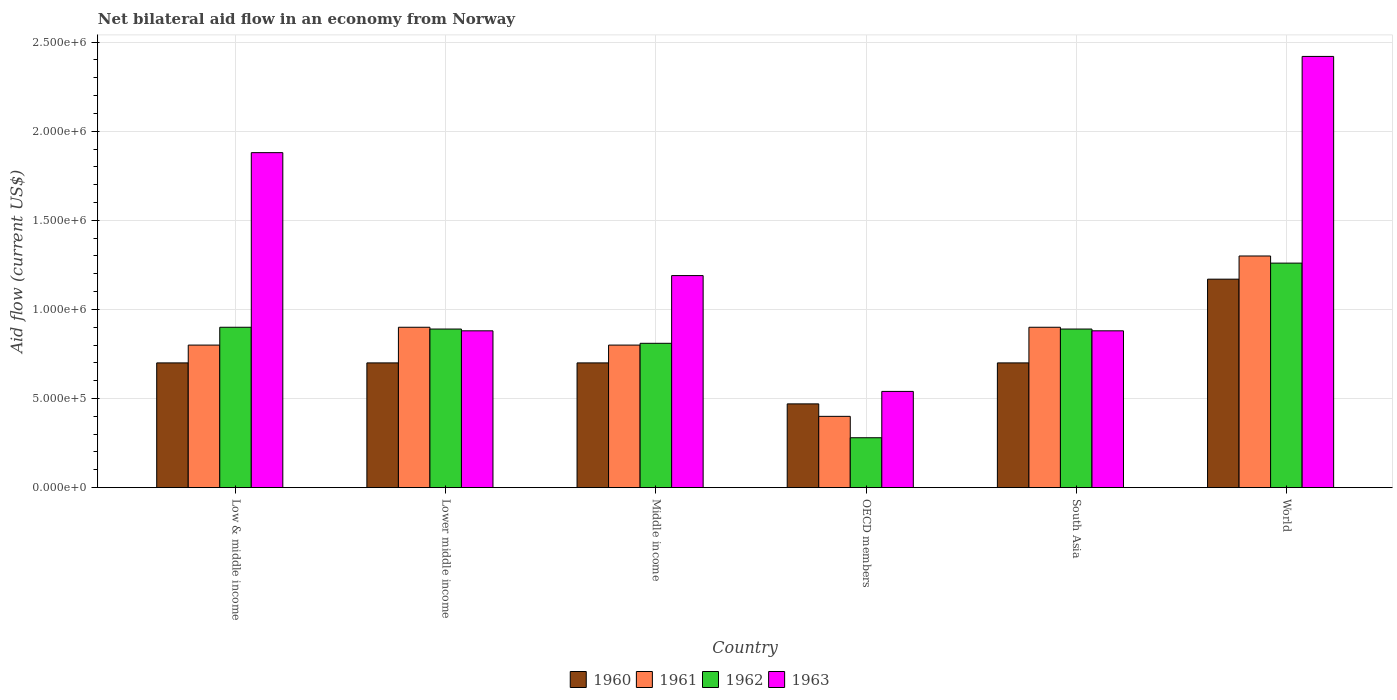How many different coloured bars are there?
Offer a very short reply. 4. How many groups of bars are there?
Make the answer very short. 6. Are the number of bars per tick equal to the number of legend labels?
Give a very brief answer. Yes. How many bars are there on the 6th tick from the right?
Offer a very short reply. 4. What is the label of the 6th group of bars from the left?
Provide a short and direct response. World. What is the net bilateral aid flow in 1961 in World?
Your answer should be very brief. 1.30e+06. Across all countries, what is the maximum net bilateral aid flow in 1963?
Your response must be concise. 2.42e+06. In which country was the net bilateral aid flow in 1961 minimum?
Provide a short and direct response. OECD members. What is the total net bilateral aid flow in 1960 in the graph?
Provide a short and direct response. 4.44e+06. What is the difference between the net bilateral aid flow in 1963 in Low & middle income and the net bilateral aid flow in 1961 in Middle income?
Ensure brevity in your answer.  1.08e+06. What is the average net bilateral aid flow in 1960 per country?
Make the answer very short. 7.40e+05. What is the difference between the net bilateral aid flow of/in 1962 and net bilateral aid flow of/in 1961 in Middle income?
Your answer should be compact. 10000. In how many countries, is the net bilateral aid flow in 1961 greater than 1200000 US$?
Your answer should be compact. 1. What is the ratio of the net bilateral aid flow in 1962 in Low & middle income to that in Middle income?
Provide a succinct answer. 1.11. What is the difference between the highest and the second highest net bilateral aid flow in 1962?
Offer a very short reply. 3.70e+05. What is the difference between the highest and the lowest net bilateral aid flow in 1963?
Give a very brief answer. 1.88e+06. In how many countries, is the net bilateral aid flow in 1962 greater than the average net bilateral aid flow in 1962 taken over all countries?
Make the answer very short. 4. What does the 2nd bar from the left in Low & middle income represents?
Provide a short and direct response. 1961. What does the 2nd bar from the right in Low & middle income represents?
Keep it short and to the point. 1962. Is it the case that in every country, the sum of the net bilateral aid flow in 1960 and net bilateral aid flow in 1962 is greater than the net bilateral aid flow in 1963?
Offer a terse response. No. Are all the bars in the graph horizontal?
Provide a succinct answer. No. How many countries are there in the graph?
Offer a terse response. 6. Are the values on the major ticks of Y-axis written in scientific E-notation?
Keep it short and to the point. Yes. Does the graph contain grids?
Make the answer very short. Yes. Where does the legend appear in the graph?
Provide a succinct answer. Bottom center. How are the legend labels stacked?
Your answer should be very brief. Horizontal. What is the title of the graph?
Offer a very short reply. Net bilateral aid flow in an economy from Norway. What is the Aid flow (current US$) in 1963 in Low & middle income?
Your answer should be very brief. 1.88e+06. What is the Aid flow (current US$) of 1961 in Lower middle income?
Provide a short and direct response. 9.00e+05. What is the Aid flow (current US$) in 1962 in Lower middle income?
Make the answer very short. 8.90e+05. What is the Aid flow (current US$) of 1963 in Lower middle income?
Your response must be concise. 8.80e+05. What is the Aid flow (current US$) in 1960 in Middle income?
Keep it short and to the point. 7.00e+05. What is the Aid flow (current US$) of 1961 in Middle income?
Keep it short and to the point. 8.00e+05. What is the Aid flow (current US$) in 1962 in Middle income?
Your answer should be compact. 8.10e+05. What is the Aid flow (current US$) in 1963 in Middle income?
Keep it short and to the point. 1.19e+06. What is the Aid flow (current US$) of 1961 in OECD members?
Your response must be concise. 4.00e+05. What is the Aid flow (current US$) of 1963 in OECD members?
Provide a short and direct response. 5.40e+05. What is the Aid flow (current US$) of 1961 in South Asia?
Provide a succinct answer. 9.00e+05. What is the Aid flow (current US$) of 1962 in South Asia?
Provide a short and direct response. 8.90e+05. What is the Aid flow (current US$) in 1963 in South Asia?
Ensure brevity in your answer.  8.80e+05. What is the Aid flow (current US$) of 1960 in World?
Provide a short and direct response. 1.17e+06. What is the Aid flow (current US$) in 1961 in World?
Provide a short and direct response. 1.30e+06. What is the Aid flow (current US$) in 1962 in World?
Your response must be concise. 1.26e+06. What is the Aid flow (current US$) in 1963 in World?
Offer a terse response. 2.42e+06. Across all countries, what is the maximum Aid flow (current US$) of 1960?
Your response must be concise. 1.17e+06. Across all countries, what is the maximum Aid flow (current US$) in 1961?
Keep it short and to the point. 1.30e+06. Across all countries, what is the maximum Aid flow (current US$) in 1962?
Provide a succinct answer. 1.26e+06. Across all countries, what is the maximum Aid flow (current US$) of 1963?
Provide a short and direct response. 2.42e+06. Across all countries, what is the minimum Aid flow (current US$) in 1961?
Provide a succinct answer. 4.00e+05. Across all countries, what is the minimum Aid flow (current US$) of 1963?
Offer a very short reply. 5.40e+05. What is the total Aid flow (current US$) of 1960 in the graph?
Your response must be concise. 4.44e+06. What is the total Aid flow (current US$) in 1961 in the graph?
Your response must be concise. 5.10e+06. What is the total Aid flow (current US$) in 1962 in the graph?
Provide a succinct answer. 5.03e+06. What is the total Aid flow (current US$) in 1963 in the graph?
Provide a short and direct response. 7.79e+06. What is the difference between the Aid flow (current US$) of 1960 in Low & middle income and that in Lower middle income?
Ensure brevity in your answer.  0. What is the difference between the Aid flow (current US$) of 1961 in Low & middle income and that in Lower middle income?
Offer a very short reply. -1.00e+05. What is the difference between the Aid flow (current US$) in 1962 in Low & middle income and that in Lower middle income?
Make the answer very short. 10000. What is the difference between the Aid flow (current US$) of 1961 in Low & middle income and that in Middle income?
Your response must be concise. 0. What is the difference between the Aid flow (current US$) in 1962 in Low & middle income and that in Middle income?
Ensure brevity in your answer.  9.00e+04. What is the difference between the Aid flow (current US$) in 1963 in Low & middle income and that in Middle income?
Your answer should be compact. 6.90e+05. What is the difference between the Aid flow (current US$) of 1962 in Low & middle income and that in OECD members?
Offer a very short reply. 6.20e+05. What is the difference between the Aid flow (current US$) in 1963 in Low & middle income and that in OECD members?
Offer a terse response. 1.34e+06. What is the difference between the Aid flow (current US$) of 1960 in Low & middle income and that in South Asia?
Your answer should be very brief. 0. What is the difference between the Aid flow (current US$) of 1961 in Low & middle income and that in South Asia?
Ensure brevity in your answer.  -1.00e+05. What is the difference between the Aid flow (current US$) in 1962 in Low & middle income and that in South Asia?
Make the answer very short. 10000. What is the difference between the Aid flow (current US$) in 1960 in Low & middle income and that in World?
Keep it short and to the point. -4.70e+05. What is the difference between the Aid flow (current US$) of 1961 in Low & middle income and that in World?
Offer a terse response. -5.00e+05. What is the difference between the Aid flow (current US$) in 1962 in Low & middle income and that in World?
Your answer should be compact. -3.60e+05. What is the difference between the Aid flow (current US$) of 1963 in Low & middle income and that in World?
Ensure brevity in your answer.  -5.40e+05. What is the difference between the Aid flow (current US$) in 1960 in Lower middle income and that in Middle income?
Make the answer very short. 0. What is the difference between the Aid flow (current US$) of 1961 in Lower middle income and that in Middle income?
Your answer should be very brief. 1.00e+05. What is the difference between the Aid flow (current US$) in 1962 in Lower middle income and that in Middle income?
Offer a terse response. 8.00e+04. What is the difference between the Aid flow (current US$) in 1963 in Lower middle income and that in Middle income?
Ensure brevity in your answer.  -3.10e+05. What is the difference between the Aid flow (current US$) of 1960 in Lower middle income and that in OECD members?
Your response must be concise. 2.30e+05. What is the difference between the Aid flow (current US$) of 1961 in Lower middle income and that in OECD members?
Make the answer very short. 5.00e+05. What is the difference between the Aid flow (current US$) in 1963 in Lower middle income and that in OECD members?
Make the answer very short. 3.40e+05. What is the difference between the Aid flow (current US$) of 1962 in Lower middle income and that in South Asia?
Ensure brevity in your answer.  0. What is the difference between the Aid flow (current US$) of 1960 in Lower middle income and that in World?
Your answer should be very brief. -4.70e+05. What is the difference between the Aid flow (current US$) of 1961 in Lower middle income and that in World?
Your response must be concise. -4.00e+05. What is the difference between the Aid flow (current US$) in 1962 in Lower middle income and that in World?
Your answer should be compact. -3.70e+05. What is the difference between the Aid flow (current US$) of 1963 in Lower middle income and that in World?
Your response must be concise. -1.54e+06. What is the difference between the Aid flow (current US$) in 1962 in Middle income and that in OECD members?
Your answer should be compact. 5.30e+05. What is the difference between the Aid flow (current US$) in 1963 in Middle income and that in OECD members?
Provide a succinct answer. 6.50e+05. What is the difference between the Aid flow (current US$) in 1961 in Middle income and that in South Asia?
Your answer should be compact. -1.00e+05. What is the difference between the Aid flow (current US$) of 1963 in Middle income and that in South Asia?
Ensure brevity in your answer.  3.10e+05. What is the difference between the Aid flow (current US$) in 1960 in Middle income and that in World?
Your answer should be compact. -4.70e+05. What is the difference between the Aid flow (current US$) of 1961 in Middle income and that in World?
Your response must be concise. -5.00e+05. What is the difference between the Aid flow (current US$) of 1962 in Middle income and that in World?
Your answer should be compact. -4.50e+05. What is the difference between the Aid flow (current US$) in 1963 in Middle income and that in World?
Your response must be concise. -1.23e+06. What is the difference between the Aid flow (current US$) of 1960 in OECD members and that in South Asia?
Make the answer very short. -2.30e+05. What is the difference between the Aid flow (current US$) in 1961 in OECD members and that in South Asia?
Your response must be concise. -5.00e+05. What is the difference between the Aid flow (current US$) in 1962 in OECD members and that in South Asia?
Offer a very short reply. -6.10e+05. What is the difference between the Aid flow (current US$) of 1963 in OECD members and that in South Asia?
Offer a very short reply. -3.40e+05. What is the difference between the Aid flow (current US$) of 1960 in OECD members and that in World?
Keep it short and to the point. -7.00e+05. What is the difference between the Aid flow (current US$) of 1961 in OECD members and that in World?
Make the answer very short. -9.00e+05. What is the difference between the Aid flow (current US$) of 1962 in OECD members and that in World?
Your response must be concise. -9.80e+05. What is the difference between the Aid flow (current US$) of 1963 in OECD members and that in World?
Give a very brief answer. -1.88e+06. What is the difference between the Aid flow (current US$) of 1960 in South Asia and that in World?
Keep it short and to the point. -4.70e+05. What is the difference between the Aid flow (current US$) of 1961 in South Asia and that in World?
Your answer should be compact. -4.00e+05. What is the difference between the Aid flow (current US$) of 1962 in South Asia and that in World?
Your answer should be compact. -3.70e+05. What is the difference between the Aid flow (current US$) of 1963 in South Asia and that in World?
Your response must be concise. -1.54e+06. What is the difference between the Aid flow (current US$) of 1960 in Low & middle income and the Aid flow (current US$) of 1962 in Lower middle income?
Provide a short and direct response. -1.90e+05. What is the difference between the Aid flow (current US$) in 1960 in Low & middle income and the Aid flow (current US$) in 1963 in Lower middle income?
Your answer should be very brief. -1.80e+05. What is the difference between the Aid flow (current US$) in 1961 in Low & middle income and the Aid flow (current US$) in 1963 in Lower middle income?
Make the answer very short. -8.00e+04. What is the difference between the Aid flow (current US$) in 1962 in Low & middle income and the Aid flow (current US$) in 1963 in Lower middle income?
Offer a terse response. 2.00e+04. What is the difference between the Aid flow (current US$) in 1960 in Low & middle income and the Aid flow (current US$) in 1963 in Middle income?
Keep it short and to the point. -4.90e+05. What is the difference between the Aid flow (current US$) in 1961 in Low & middle income and the Aid flow (current US$) in 1962 in Middle income?
Keep it short and to the point. -10000. What is the difference between the Aid flow (current US$) of 1961 in Low & middle income and the Aid flow (current US$) of 1963 in Middle income?
Provide a succinct answer. -3.90e+05. What is the difference between the Aid flow (current US$) of 1962 in Low & middle income and the Aid flow (current US$) of 1963 in Middle income?
Offer a terse response. -2.90e+05. What is the difference between the Aid flow (current US$) in 1960 in Low & middle income and the Aid flow (current US$) in 1962 in OECD members?
Give a very brief answer. 4.20e+05. What is the difference between the Aid flow (current US$) in 1960 in Low & middle income and the Aid flow (current US$) in 1963 in OECD members?
Ensure brevity in your answer.  1.60e+05. What is the difference between the Aid flow (current US$) of 1961 in Low & middle income and the Aid flow (current US$) of 1962 in OECD members?
Your response must be concise. 5.20e+05. What is the difference between the Aid flow (current US$) of 1962 in Low & middle income and the Aid flow (current US$) of 1963 in OECD members?
Keep it short and to the point. 3.60e+05. What is the difference between the Aid flow (current US$) in 1960 in Low & middle income and the Aid flow (current US$) in 1961 in South Asia?
Offer a very short reply. -2.00e+05. What is the difference between the Aid flow (current US$) in 1960 in Low & middle income and the Aid flow (current US$) in 1963 in South Asia?
Offer a terse response. -1.80e+05. What is the difference between the Aid flow (current US$) in 1960 in Low & middle income and the Aid flow (current US$) in 1961 in World?
Give a very brief answer. -6.00e+05. What is the difference between the Aid flow (current US$) of 1960 in Low & middle income and the Aid flow (current US$) of 1962 in World?
Provide a succinct answer. -5.60e+05. What is the difference between the Aid flow (current US$) in 1960 in Low & middle income and the Aid flow (current US$) in 1963 in World?
Your response must be concise. -1.72e+06. What is the difference between the Aid flow (current US$) of 1961 in Low & middle income and the Aid flow (current US$) of 1962 in World?
Offer a terse response. -4.60e+05. What is the difference between the Aid flow (current US$) in 1961 in Low & middle income and the Aid flow (current US$) in 1963 in World?
Offer a terse response. -1.62e+06. What is the difference between the Aid flow (current US$) of 1962 in Low & middle income and the Aid flow (current US$) of 1963 in World?
Ensure brevity in your answer.  -1.52e+06. What is the difference between the Aid flow (current US$) in 1960 in Lower middle income and the Aid flow (current US$) in 1962 in Middle income?
Provide a short and direct response. -1.10e+05. What is the difference between the Aid flow (current US$) in 1960 in Lower middle income and the Aid flow (current US$) in 1963 in Middle income?
Make the answer very short. -4.90e+05. What is the difference between the Aid flow (current US$) of 1961 in Lower middle income and the Aid flow (current US$) of 1962 in OECD members?
Keep it short and to the point. 6.20e+05. What is the difference between the Aid flow (current US$) in 1960 in Lower middle income and the Aid flow (current US$) in 1961 in South Asia?
Offer a terse response. -2.00e+05. What is the difference between the Aid flow (current US$) of 1960 in Lower middle income and the Aid flow (current US$) of 1963 in South Asia?
Offer a terse response. -1.80e+05. What is the difference between the Aid flow (current US$) of 1961 in Lower middle income and the Aid flow (current US$) of 1963 in South Asia?
Provide a succinct answer. 2.00e+04. What is the difference between the Aid flow (current US$) in 1960 in Lower middle income and the Aid flow (current US$) in 1961 in World?
Keep it short and to the point. -6.00e+05. What is the difference between the Aid flow (current US$) of 1960 in Lower middle income and the Aid flow (current US$) of 1962 in World?
Make the answer very short. -5.60e+05. What is the difference between the Aid flow (current US$) in 1960 in Lower middle income and the Aid flow (current US$) in 1963 in World?
Your answer should be compact. -1.72e+06. What is the difference between the Aid flow (current US$) in 1961 in Lower middle income and the Aid flow (current US$) in 1962 in World?
Provide a short and direct response. -3.60e+05. What is the difference between the Aid flow (current US$) of 1961 in Lower middle income and the Aid flow (current US$) of 1963 in World?
Your answer should be compact. -1.52e+06. What is the difference between the Aid flow (current US$) in 1962 in Lower middle income and the Aid flow (current US$) in 1963 in World?
Ensure brevity in your answer.  -1.53e+06. What is the difference between the Aid flow (current US$) in 1961 in Middle income and the Aid flow (current US$) in 1962 in OECD members?
Offer a terse response. 5.20e+05. What is the difference between the Aid flow (current US$) in 1962 in Middle income and the Aid flow (current US$) in 1963 in OECD members?
Ensure brevity in your answer.  2.70e+05. What is the difference between the Aid flow (current US$) in 1960 in Middle income and the Aid flow (current US$) in 1962 in South Asia?
Make the answer very short. -1.90e+05. What is the difference between the Aid flow (current US$) in 1960 in Middle income and the Aid flow (current US$) in 1963 in South Asia?
Offer a very short reply. -1.80e+05. What is the difference between the Aid flow (current US$) of 1960 in Middle income and the Aid flow (current US$) of 1961 in World?
Your response must be concise. -6.00e+05. What is the difference between the Aid flow (current US$) in 1960 in Middle income and the Aid flow (current US$) in 1962 in World?
Offer a terse response. -5.60e+05. What is the difference between the Aid flow (current US$) in 1960 in Middle income and the Aid flow (current US$) in 1963 in World?
Your response must be concise. -1.72e+06. What is the difference between the Aid flow (current US$) of 1961 in Middle income and the Aid flow (current US$) of 1962 in World?
Offer a terse response. -4.60e+05. What is the difference between the Aid flow (current US$) in 1961 in Middle income and the Aid flow (current US$) in 1963 in World?
Provide a short and direct response. -1.62e+06. What is the difference between the Aid flow (current US$) in 1962 in Middle income and the Aid flow (current US$) in 1963 in World?
Ensure brevity in your answer.  -1.61e+06. What is the difference between the Aid flow (current US$) in 1960 in OECD members and the Aid flow (current US$) in 1961 in South Asia?
Make the answer very short. -4.30e+05. What is the difference between the Aid flow (current US$) of 1960 in OECD members and the Aid flow (current US$) of 1962 in South Asia?
Ensure brevity in your answer.  -4.20e+05. What is the difference between the Aid flow (current US$) in 1960 in OECD members and the Aid flow (current US$) in 1963 in South Asia?
Provide a succinct answer. -4.10e+05. What is the difference between the Aid flow (current US$) of 1961 in OECD members and the Aid flow (current US$) of 1962 in South Asia?
Keep it short and to the point. -4.90e+05. What is the difference between the Aid flow (current US$) in 1961 in OECD members and the Aid flow (current US$) in 1963 in South Asia?
Keep it short and to the point. -4.80e+05. What is the difference between the Aid flow (current US$) of 1962 in OECD members and the Aid flow (current US$) of 1963 in South Asia?
Offer a very short reply. -6.00e+05. What is the difference between the Aid flow (current US$) in 1960 in OECD members and the Aid flow (current US$) in 1961 in World?
Provide a short and direct response. -8.30e+05. What is the difference between the Aid flow (current US$) in 1960 in OECD members and the Aid flow (current US$) in 1962 in World?
Offer a terse response. -7.90e+05. What is the difference between the Aid flow (current US$) of 1960 in OECD members and the Aid flow (current US$) of 1963 in World?
Give a very brief answer. -1.95e+06. What is the difference between the Aid flow (current US$) of 1961 in OECD members and the Aid flow (current US$) of 1962 in World?
Your response must be concise. -8.60e+05. What is the difference between the Aid flow (current US$) in 1961 in OECD members and the Aid flow (current US$) in 1963 in World?
Provide a short and direct response. -2.02e+06. What is the difference between the Aid flow (current US$) in 1962 in OECD members and the Aid flow (current US$) in 1963 in World?
Keep it short and to the point. -2.14e+06. What is the difference between the Aid flow (current US$) of 1960 in South Asia and the Aid flow (current US$) of 1961 in World?
Give a very brief answer. -6.00e+05. What is the difference between the Aid flow (current US$) in 1960 in South Asia and the Aid flow (current US$) in 1962 in World?
Provide a short and direct response. -5.60e+05. What is the difference between the Aid flow (current US$) in 1960 in South Asia and the Aid flow (current US$) in 1963 in World?
Your response must be concise. -1.72e+06. What is the difference between the Aid flow (current US$) of 1961 in South Asia and the Aid flow (current US$) of 1962 in World?
Offer a terse response. -3.60e+05. What is the difference between the Aid flow (current US$) of 1961 in South Asia and the Aid flow (current US$) of 1963 in World?
Ensure brevity in your answer.  -1.52e+06. What is the difference between the Aid flow (current US$) in 1962 in South Asia and the Aid flow (current US$) in 1963 in World?
Provide a succinct answer. -1.53e+06. What is the average Aid flow (current US$) in 1960 per country?
Your answer should be compact. 7.40e+05. What is the average Aid flow (current US$) in 1961 per country?
Provide a short and direct response. 8.50e+05. What is the average Aid flow (current US$) of 1962 per country?
Offer a very short reply. 8.38e+05. What is the average Aid flow (current US$) in 1963 per country?
Provide a short and direct response. 1.30e+06. What is the difference between the Aid flow (current US$) in 1960 and Aid flow (current US$) in 1961 in Low & middle income?
Keep it short and to the point. -1.00e+05. What is the difference between the Aid flow (current US$) of 1960 and Aid flow (current US$) of 1963 in Low & middle income?
Ensure brevity in your answer.  -1.18e+06. What is the difference between the Aid flow (current US$) of 1961 and Aid flow (current US$) of 1962 in Low & middle income?
Your response must be concise. -1.00e+05. What is the difference between the Aid flow (current US$) in 1961 and Aid flow (current US$) in 1963 in Low & middle income?
Your answer should be compact. -1.08e+06. What is the difference between the Aid flow (current US$) of 1962 and Aid flow (current US$) of 1963 in Low & middle income?
Offer a very short reply. -9.80e+05. What is the difference between the Aid flow (current US$) in 1960 and Aid flow (current US$) in 1961 in Lower middle income?
Provide a short and direct response. -2.00e+05. What is the difference between the Aid flow (current US$) in 1960 and Aid flow (current US$) in 1962 in Lower middle income?
Offer a very short reply. -1.90e+05. What is the difference between the Aid flow (current US$) in 1960 and Aid flow (current US$) in 1963 in Lower middle income?
Make the answer very short. -1.80e+05. What is the difference between the Aid flow (current US$) in 1962 and Aid flow (current US$) in 1963 in Lower middle income?
Make the answer very short. 10000. What is the difference between the Aid flow (current US$) of 1960 and Aid flow (current US$) of 1961 in Middle income?
Your answer should be very brief. -1.00e+05. What is the difference between the Aid flow (current US$) in 1960 and Aid flow (current US$) in 1962 in Middle income?
Keep it short and to the point. -1.10e+05. What is the difference between the Aid flow (current US$) in 1960 and Aid flow (current US$) in 1963 in Middle income?
Provide a short and direct response. -4.90e+05. What is the difference between the Aid flow (current US$) in 1961 and Aid flow (current US$) in 1962 in Middle income?
Provide a succinct answer. -10000. What is the difference between the Aid flow (current US$) of 1961 and Aid flow (current US$) of 1963 in Middle income?
Provide a short and direct response. -3.90e+05. What is the difference between the Aid flow (current US$) of 1962 and Aid flow (current US$) of 1963 in Middle income?
Your response must be concise. -3.80e+05. What is the difference between the Aid flow (current US$) in 1960 and Aid flow (current US$) in 1961 in OECD members?
Make the answer very short. 7.00e+04. What is the difference between the Aid flow (current US$) of 1961 and Aid flow (current US$) of 1962 in OECD members?
Ensure brevity in your answer.  1.20e+05. What is the difference between the Aid flow (current US$) of 1960 and Aid flow (current US$) of 1961 in South Asia?
Offer a very short reply. -2.00e+05. What is the difference between the Aid flow (current US$) of 1960 and Aid flow (current US$) of 1963 in South Asia?
Make the answer very short. -1.80e+05. What is the difference between the Aid flow (current US$) in 1962 and Aid flow (current US$) in 1963 in South Asia?
Make the answer very short. 10000. What is the difference between the Aid flow (current US$) of 1960 and Aid flow (current US$) of 1962 in World?
Provide a short and direct response. -9.00e+04. What is the difference between the Aid flow (current US$) of 1960 and Aid flow (current US$) of 1963 in World?
Keep it short and to the point. -1.25e+06. What is the difference between the Aid flow (current US$) in 1961 and Aid flow (current US$) in 1963 in World?
Provide a short and direct response. -1.12e+06. What is the difference between the Aid flow (current US$) in 1962 and Aid flow (current US$) in 1963 in World?
Offer a terse response. -1.16e+06. What is the ratio of the Aid flow (current US$) in 1961 in Low & middle income to that in Lower middle income?
Make the answer very short. 0.89. What is the ratio of the Aid flow (current US$) of 1962 in Low & middle income to that in Lower middle income?
Your response must be concise. 1.01. What is the ratio of the Aid flow (current US$) of 1963 in Low & middle income to that in Lower middle income?
Offer a terse response. 2.14. What is the ratio of the Aid flow (current US$) of 1963 in Low & middle income to that in Middle income?
Make the answer very short. 1.58. What is the ratio of the Aid flow (current US$) in 1960 in Low & middle income to that in OECD members?
Ensure brevity in your answer.  1.49. What is the ratio of the Aid flow (current US$) in 1962 in Low & middle income to that in OECD members?
Make the answer very short. 3.21. What is the ratio of the Aid flow (current US$) of 1963 in Low & middle income to that in OECD members?
Your response must be concise. 3.48. What is the ratio of the Aid flow (current US$) of 1960 in Low & middle income to that in South Asia?
Provide a short and direct response. 1. What is the ratio of the Aid flow (current US$) in 1962 in Low & middle income to that in South Asia?
Your response must be concise. 1.01. What is the ratio of the Aid flow (current US$) in 1963 in Low & middle income to that in South Asia?
Provide a short and direct response. 2.14. What is the ratio of the Aid flow (current US$) of 1960 in Low & middle income to that in World?
Your answer should be compact. 0.6. What is the ratio of the Aid flow (current US$) in 1961 in Low & middle income to that in World?
Your response must be concise. 0.62. What is the ratio of the Aid flow (current US$) of 1962 in Low & middle income to that in World?
Give a very brief answer. 0.71. What is the ratio of the Aid flow (current US$) of 1963 in Low & middle income to that in World?
Your answer should be compact. 0.78. What is the ratio of the Aid flow (current US$) in 1961 in Lower middle income to that in Middle income?
Give a very brief answer. 1.12. What is the ratio of the Aid flow (current US$) in 1962 in Lower middle income to that in Middle income?
Provide a short and direct response. 1.1. What is the ratio of the Aid flow (current US$) in 1963 in Lower middle income to that in Middle income?
Your answer should be very brief. 0.74. What is the ratio of the Aid flow (current US$) of 1960 in Lower middle income to that in OECD members?
Your response must be concise. 1.49. What is the ratio of the Aid flow (current US$) in 1961 in Lower middle income to that in OECD members?
Your answer should be compact. 2.25. What is the ratio of the Aid flow (current US$) in 1962 in Lower middle income to that in OECD members?
Offer a very short reply. 3.18. What is the ratio of the Aid flow (current US$) of 1963 in Lower middle income to that in OECD members?
Ensure brevity in your answer.  1.63. What is the ratio of the Aid flow (current US$) in 1962 in Lower middle income to that in South Asia?
Ensure brevity in your answer.  1. What is the ratio of the Aid flow (current US$) in 1963 in Lower middle income to that in South Asia?
Keep it short and to the point. 1. What is the ratio of the Aid flow (current US$) of 1960 in Lower middle income to that in World?
Provide a short and direct response. 0.6. What is the ratio of the Aid flow (current US$) in 1961 in Lower middle income to that in World?
Provide a succinct answer. 0.69. What is the ratio of the Aid flow (current US$) of 1962 in Lower middle income to that in World?
Offer a terse response. 0.71. What is the ratio of the Aid flow (current US$) of 1963 in Lower middle income to that in World?
Your answer should be very brief. 0.36. What is the ratio of the Aid flow (current US$) of 1960 in Middle income to that in OECD members?
Offer a terse response. 1.49. What is the ratio of the Aid flow (current US$) in 1962 in Middle income to that in OECD members?
Make the answer very short. 2.89. What is the ratio of the Aid flow (current US$) in 1963 in Middle income to that in OECD members?
Provide a short and direct response. 2.2. What is the ratio of the Aid flow (current US$) of 1960 in Middle income to that in South Asia?
Offer a very short reply. 1. What is the ratio of the Aid flow (current US$) of 1961 in Middle income to that in South Asia?
Offer a very short reply. 0.89. What is the ratio of the Aid flow (current US$) of 1962 in Middle income to that in South Asia?
Your answer should be very brief. 0.91. What is the ratio of the Aid flow (current US$) in 1963 in Middle income to that in South Asia?
Your response must be concise. 1.35. What is the ratio of the Aid flow (current US$) of 1960 in Middle income to that in World?
Give a very brief answer. 0.6. What is the ratio of the Aid flow (current US$) of 1961 in Middle income to that in World?
Make the answer very short. 0.62. What is the ratio of the Aid flow (current US$) in 1962 in Middle income to that in World?
Ensure brevity in your answer.  0.64. What is the ratio of the Aid flow (current US$) of 1963 in Middle income to that in World?
Keep it short and to the point. 0.49. What is the ratio of the Aid flow (current US$) of 1960 in OECD members to that in South Asia?
Provide a succinct answer. 0.67. What is the ratio of the Aid flow (current US$) in 1961 in OECD members to that in South Asia?
Your answer should be compact. 0.44. What is the ratio of the Aid flow (current US$) of 1962 in OECD members to that in South Asia?
Your answer should be very brief. 0.31. What is the ratio of the Aid flow (current US$) of 1963 in OECD members to that in South Asia?
Keep it short and to the point. 0.61. What is the ratio of the Aid flow (current US$) in 1960 in OECD members to that in World?
Offer a terse response. 0.4. What is the ratio of the Aid flow (current US$) of 1961 in OECD members to that in World?
Ensure brevity in your answer.  0.31. What is the ratio of the Aid flow (current US$) of 1962 in OECD members to that in World?
Your answer should be compact. 0.22. What is the ratio of the Aid flow (current US$) of 1963 in OECD members to that in World?
Give a very brief answer. 0.22. What is the ratio of the Aid flow (current US$) of 1960 in South Asia to that in World?
Offer a very short reply. 0.6. What is the ratio of the Aid flow (current US$) of 1961 in South Asia to that in World?
Offer a very short reply. 0.69. What is the ratio of the Aid flow (current US$) in 1962 in South Asia to that in World?
Offer a terse response. 0.71. What is the ratio of the Aid flow (current US$) of 1963 in South Asia to that in World?
Your answer should be compact. 0.36. What is the difference between the highest and the second highest Aid flow (current US$) in 1961?
Give a very brief answer. 4.00e+05. What is the difference between the highest and the second highest Aid flow (current US$) in 1963?
Offer a terse response. 5.40e+05. What is the difference between the highest and the lowest Aid flow (current US$) of 1960?
Make the answer very short. 7.00e+05. What is the difference between the highest and the lowest Aid flow (current US$) in 1962?
Keep it short and to the point. 9.80e+05. What is the difference between the highest and the lowest Aid flow (current US$) in 1963?
Provide a succinct answer. 1.88e+06. 